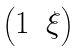<formula> <loc_0><loc_0><loc_500><loc_500>\begin{pmatrix} 1 & \xi \end{pmatrix}</formula> 